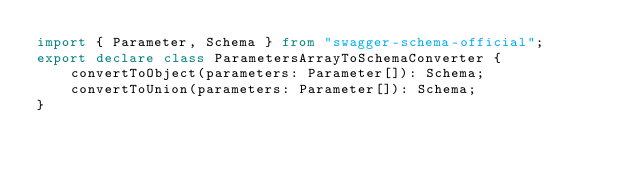<code> <loc_0><loc_0><loc_500><loc_500><_TypeScript_>import { Parameter, Schema } from "swagger-schema-official";
export declare class ParametersArrayToSchemaConverter {
    convertToObject(parameters: Parameter[]): Schema;
    convertToUnion(parameters: Parameter[]): Schema;
}
</code> 